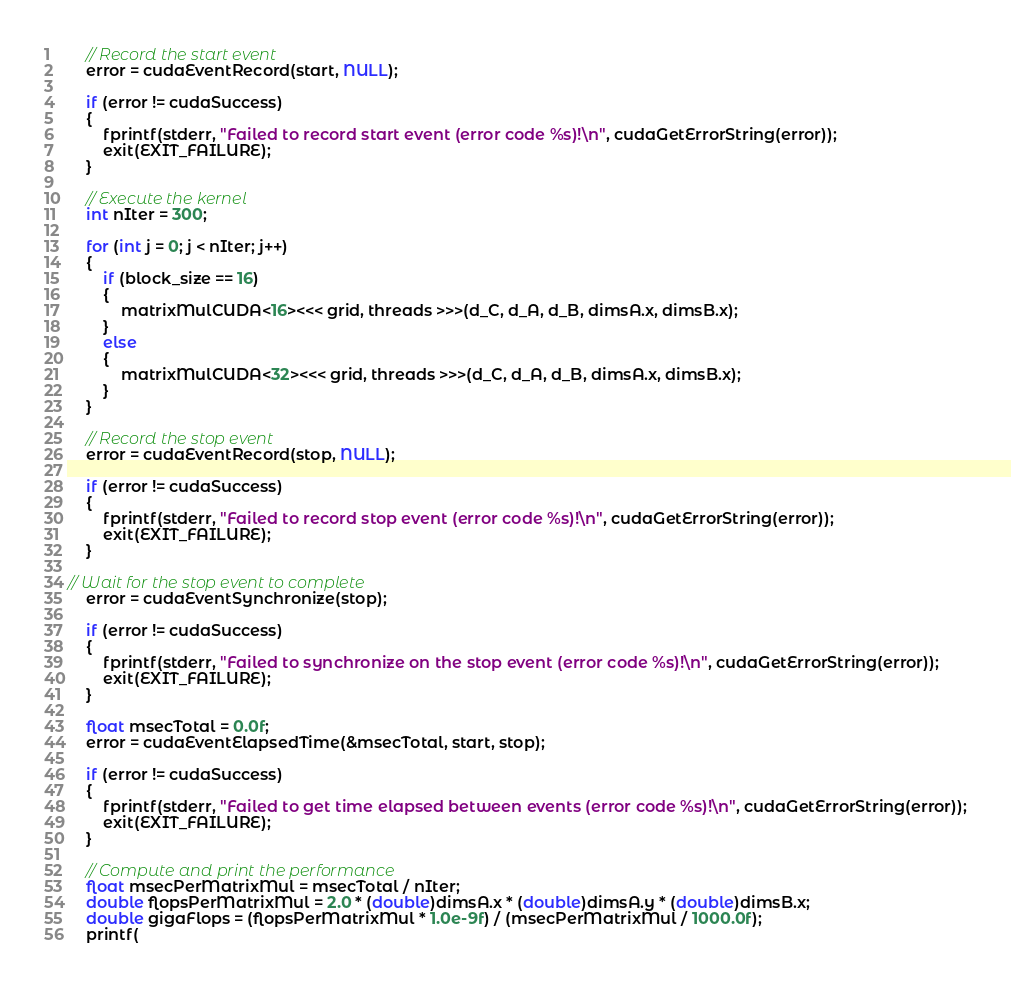<code> <loc_0><loc_0><loc_500><loc_500><_Cuda_>
    // Record the start event
    error = cudaEventRecord(start, NULL);

    if (error != cudaSuccess)
    {
        fprintf(stderr, "Failed to record start event (error code %s)!\n", cudaGetErrorString(error));
        exit(EXIT_FAILURE);
    }

    // Execute the kernel
    int nIter = 300;

    for (int j = 0; j < nIter; j++)
    {
        if (block_size == 16)
        {
            matrixMulCUDA<16><<< grid, threads >>>(d_C, d_A, d_B, dimsA.x, dimsB.x);
        }
        else
        {
            matrixMulCUDA<32><<< grid, threads >>>(d_C, d_A, d_B, dimsA.x, dimsB.x);
        }
    }

    // Record the stop event
    error = cudaEventRecord(stop, NULL);

    if (error != cudaSuccess)
    {
        fprintf(stderr, "Failed to record stop event (error code %s)!\n", cudaGetErrorString(error));
        exit(EXIT_FAILURE);
    }

// Wait for the stop event to complete
    error = cudaEventSynchronize(stop);

    if (error != cudaSuccess)
    {
        fprintf(stderr, "Failed to synchronize on the stop event (error code %s)!\n", cudaGetErrorString(error));
        exit(EXIT_FAILURE);
    }

    float msecTotal = 0.0f;
    error = cudaEventElapsedTime(&msecTotal, start, stop);

    if (error != cudaSuccess)
    {
        fprintf(stderr, "Failed to get time elapsed between events (error code %s)!\n", cudaGetErrorString(error));
        exit(EXIT_FAILURE);
    }

    // Compute and print the performance
    float msecPerMatrixMul = msecTotal / nIter;
    double flopsPerMatrixMul = 2.0 * (double)dimsA.x * (double)dimsA.y * (double)dimsB.x;
    double gigaFlops = (flopsPerMatrixMul * 1.0e-9f) / (msecPerMatrixMul / 1000.0f);
    printf(</code> 